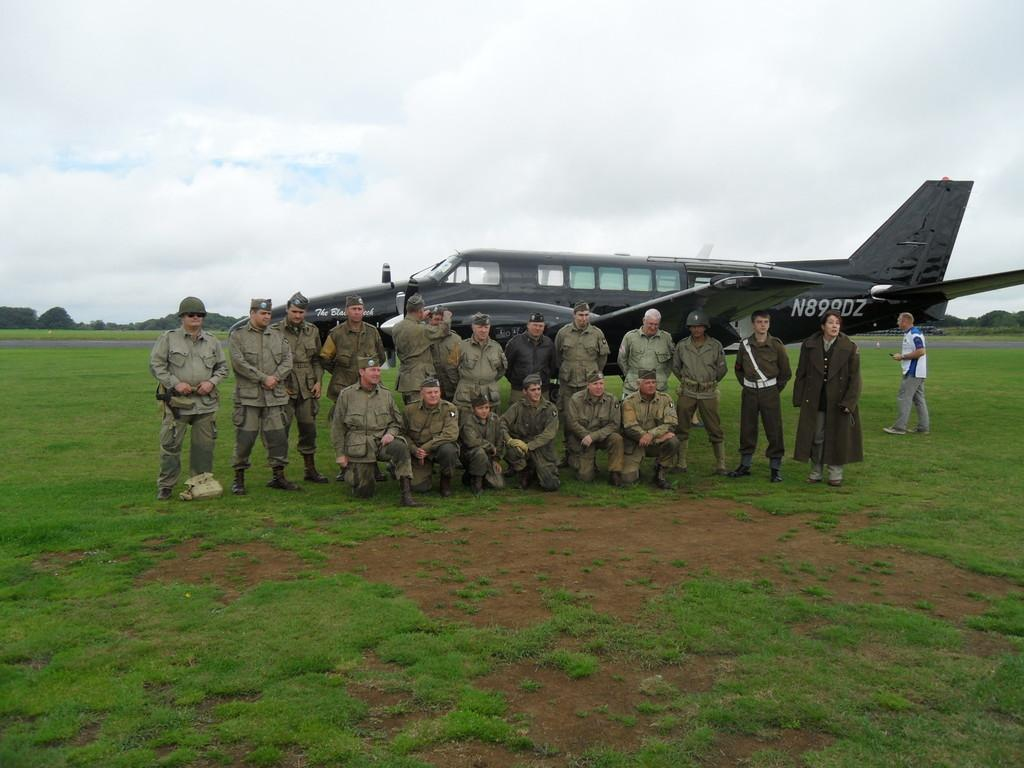<image>
Offer a succinct explanation of the picture presented. A group of people pose in front of a plane designated N899DZ. 